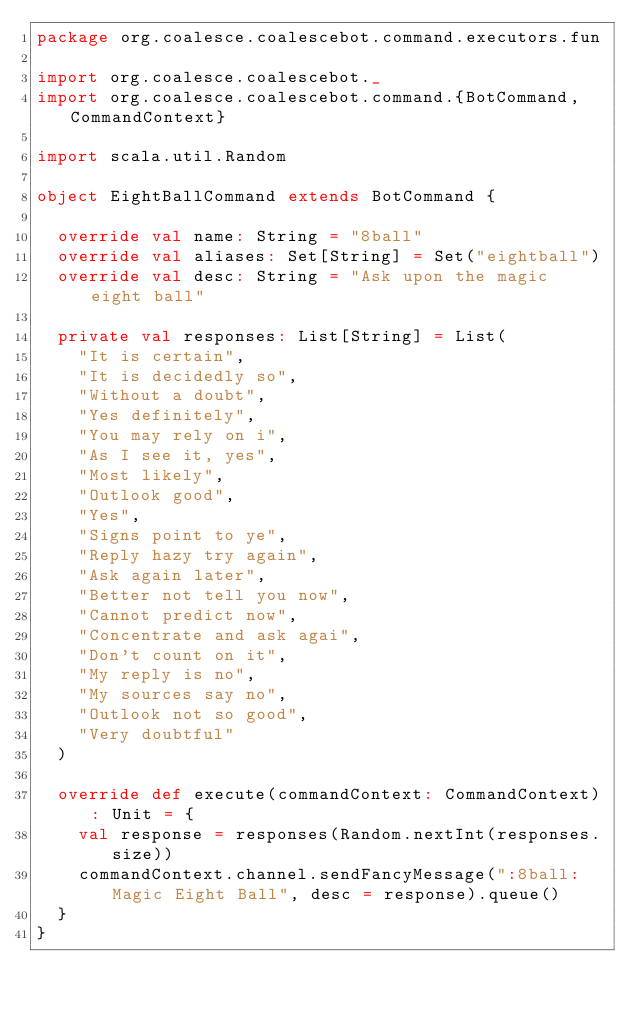Convert code to text. <code><loc_0><loc_0><loc_500><loc_500><_Scala_>package org.coalesce.coalescebot.command.executors.fun

import org.coalesce.coalescebot._
import org.coalesce.coalescebot.command.{BotCommand, CommandContext}

import scala.util.Random

object EightBallCommand extends BotCommand {

  override val name: String = "8ball"
  override val aliases: Set[String] = Set("eightball")
  override val desc: String = "Ask upon the magic eight ball"

  private val responses: List[String] = List(
    "It is certain",
    "It is decidedly so",
    "Without a doubt",
    "Yes definitely",
    "You may rely on i",
    "As I see it, yes",
    "Most likely",
    "Outlook good",
    "Yes",
    "Signs point to ye",
    "Reply hazy try again",
    "Ask again later",
    "Better not tell you now",
    "Cannot predict now",
    "Concentrate and ask agai",
    "Don't count on it",
    "My reply is no",
    "My sources say no",
    "Outlook not so good",
    "Very doubtful"
  )

  override def execute(commandContext: CommandContext): Unit = {
    val response = responses(Random.nextInt(responses.size))
    commandContext.channel.sendFancyMessage(":8ball: Magic Eight Ball", desc = response).queue()
  }
}</code> 